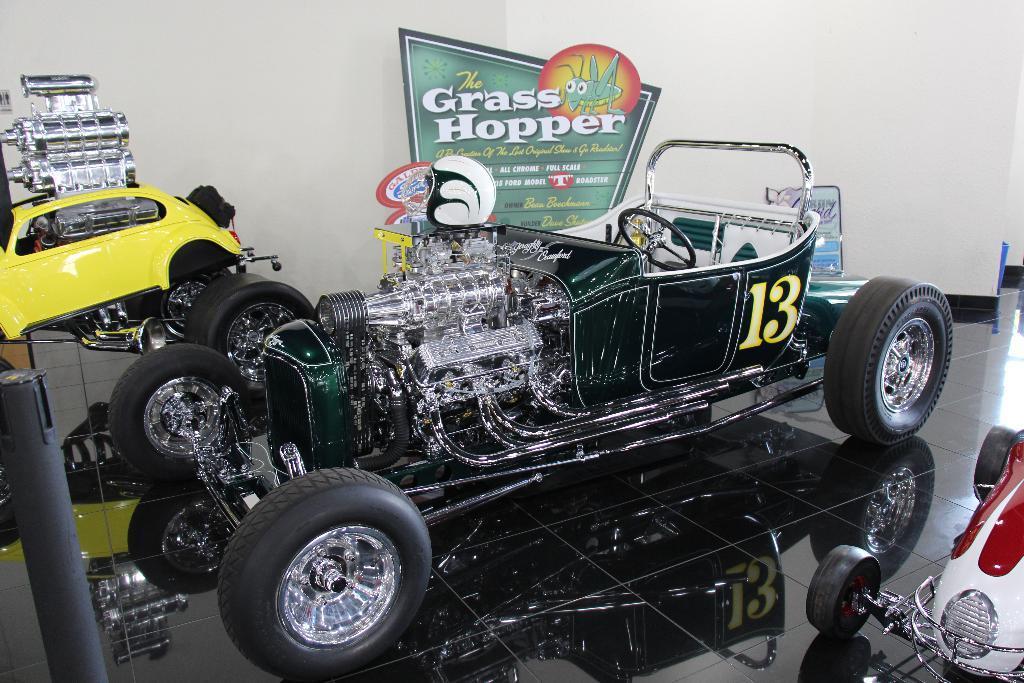Please provide a concise description of this image. In this picture there is green color car which is parked on the floor. On the left there is a yellow color car which is parked near to the wall. In the back there is a banner. 